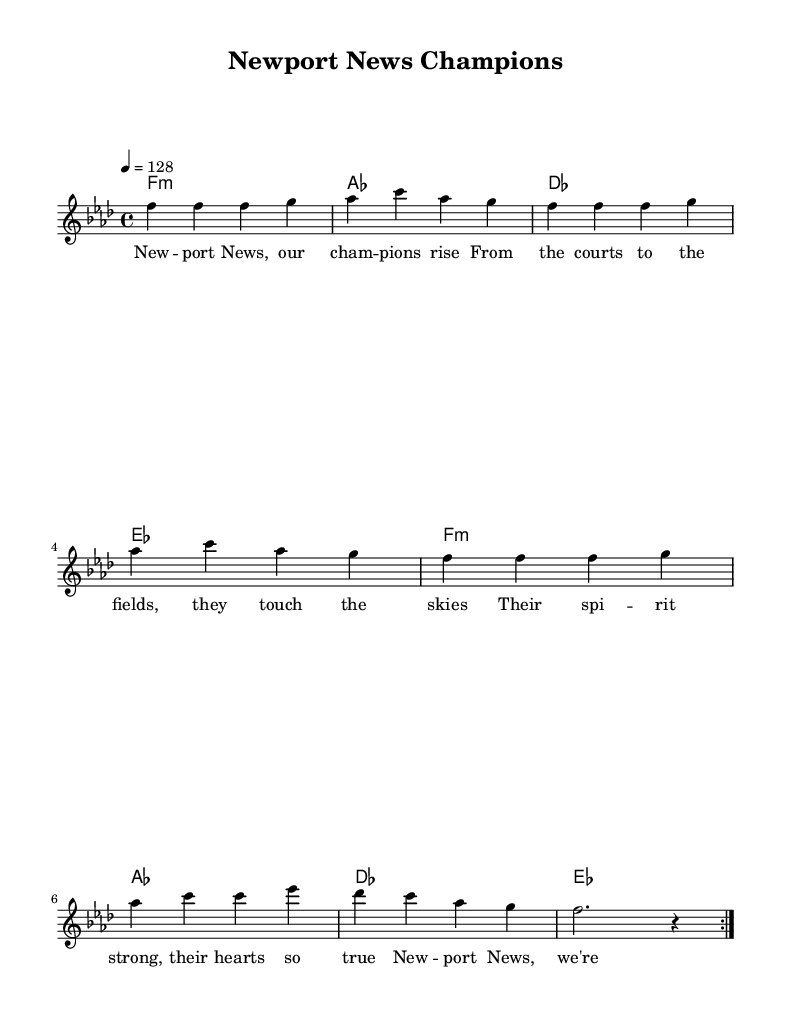What is the key signature of this music? The key signature is F minor, which has four flats. The music sheet indicates the key signature at the beginning of the score, showing the flats on the staff.
Answer: F minor What is the time signature of the piece? The time signature is 4/4, which means there are four beats in each measure and the quarter note gets one beat. This is indicated at the beginning of the score.
Answer: 4/4 What is the tempo marking for this song? The tempo marking indicates a speed of 128 beats per minute, and it specifies that the quarter note equals 128. This is noted at the beginning of the score.
Answer: 128 How many measures are repeated in the melody section? The melody section repeats two measures, as indicated by the "repeat volta 2" notation. This shows that the melody will play through twice before moving on.
Answer: 2 What are the two primary chords used in the harmony section? The primary chords in the harmony section are F minor and A flat major. By identifying the chord names listed in the harmony part, we see these two are mentioned as prominent chords.
Answer: F minor, A flat major What is the overall theme of the lyrics presented? The theme of the lyrics celebrates local sports heroes from Newport News, expressing pride in their accomplishments and spirit. This can be inferred by analyzing the content and keywords in the lyrics.
Answer: Celebrating local sports heroes 